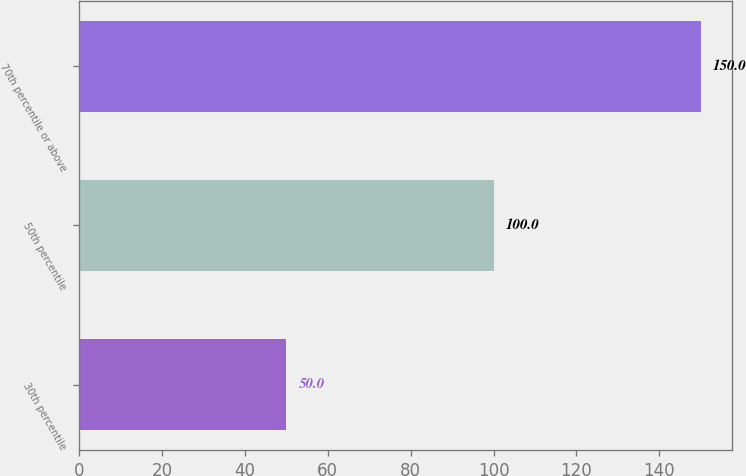Convert chart. <chart><loc_0><loc_0><loc_500><loc_500><bar_chart><fcel>30th percentile<fcel>50th percentile<fcel>70th percentile or above<nl><fcel>50<fcel>100<fcel>150<nl></chart> 